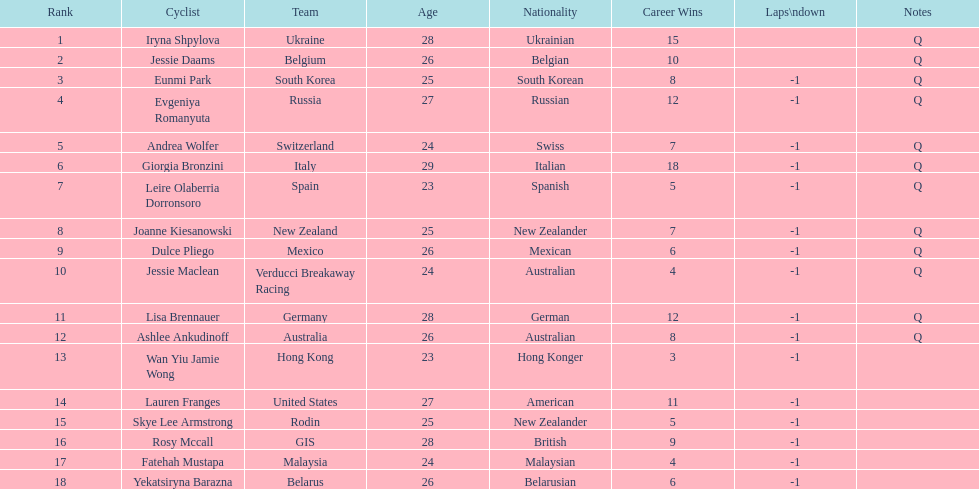How many consecutive notes are there? 12. 